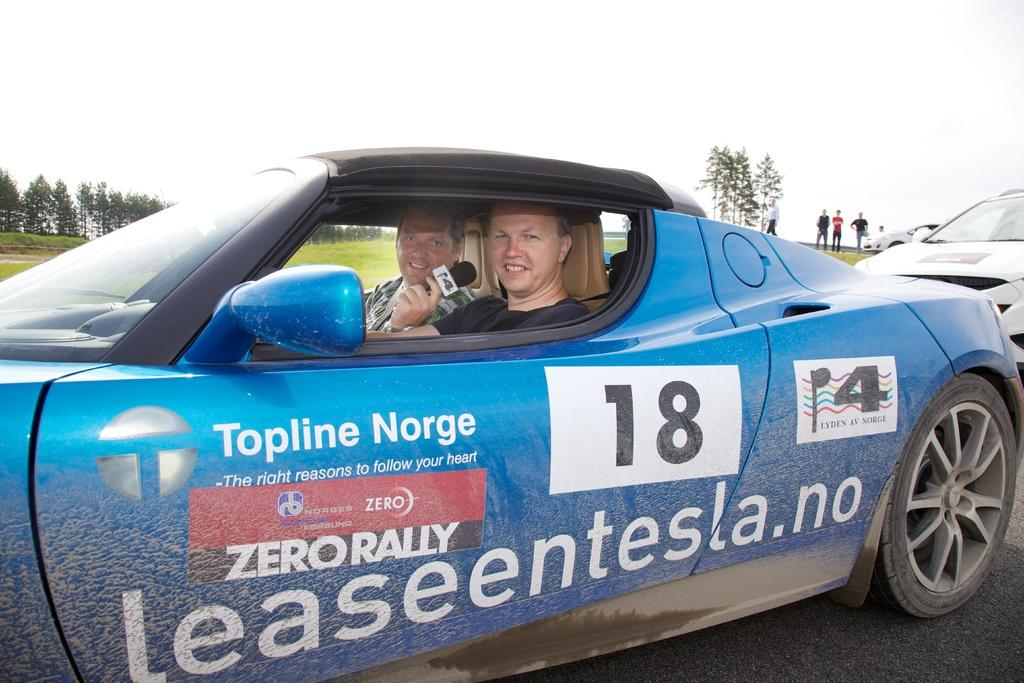How many people are inside the vehicle in the image? There are two persons inside the vehicle in the image. What is the setting of the image? The image depicts a road. Can you describe the people visible in the image? There are people visible in the image. What type of vegetation can be seen in the image? There are trees in the image. What is visible in the background of the image? The sky is visible in the image. What type of celery can be seen growing on the side of the road in the image? A: There is no celery visible in the image; it depicts a road with trees and a sky background. Can you describe the interaction between the two persons and the stranger in the image? There is no stranger present in the image; it only shows two persons inside a vehicle. 